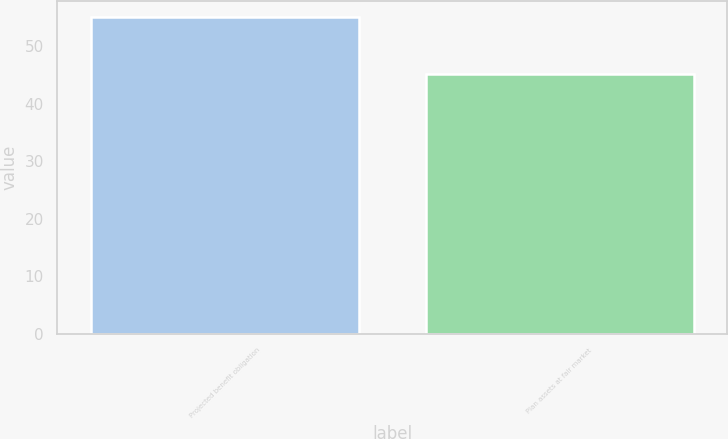<chart> <loc_0><loc_0><loc_500><loc_500><bar_chart><fcel>Projected benefit obligation<fcel>Plan assets at fair market<nl><fcel>55.1<fcel>45.2<nl></chart> 